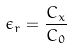<formula> <loc_0><loc_0><loc_500><loc_500>\epsilon _ { r } = \frac { C _ { x } } { C _ { 0 } }</formula> 